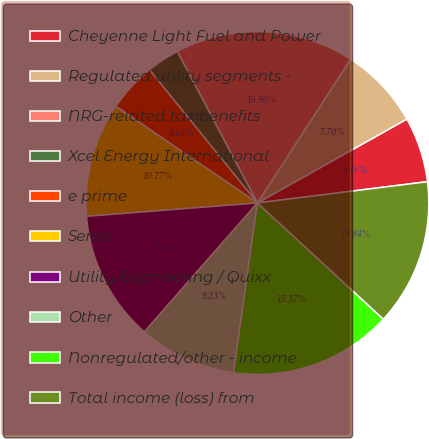Convert chart to OTSL. <chart><loc_0><loc_0><loc_500><loc_500><pie_chart><fcel>Cheyenne Light Fuel and Power<fcel>Regulated utility segments -<fcel>NRG-related tax benefits<fcel>Xcel Energy International<fcel>e prime<fcel>Seren<fcel>Utility Engineering / Quixx<fcel>Other<fcel>Nonregulated/other - income<fcel>Total income (loss) from<nl><fcel>6.16%<fcel>7.7%<fcel>16.9%<fcel>3.1%<fcel>4.63%<fcel>10.77%<fcel>12.3%<fcel>9.23%<fcel>15.37%<fcel>13.84%<nl></chart> 